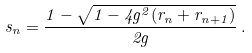Convert formula to latex. <formula><loc_0><loc_0><loc_500><loc_500>s _ { n } = \frac { 1 - \sqrt { 1 - 4 g ^ { 2 } ( r _ { n } + r _ { n + 1 } ) } } { 2 g } \, .</formula> 